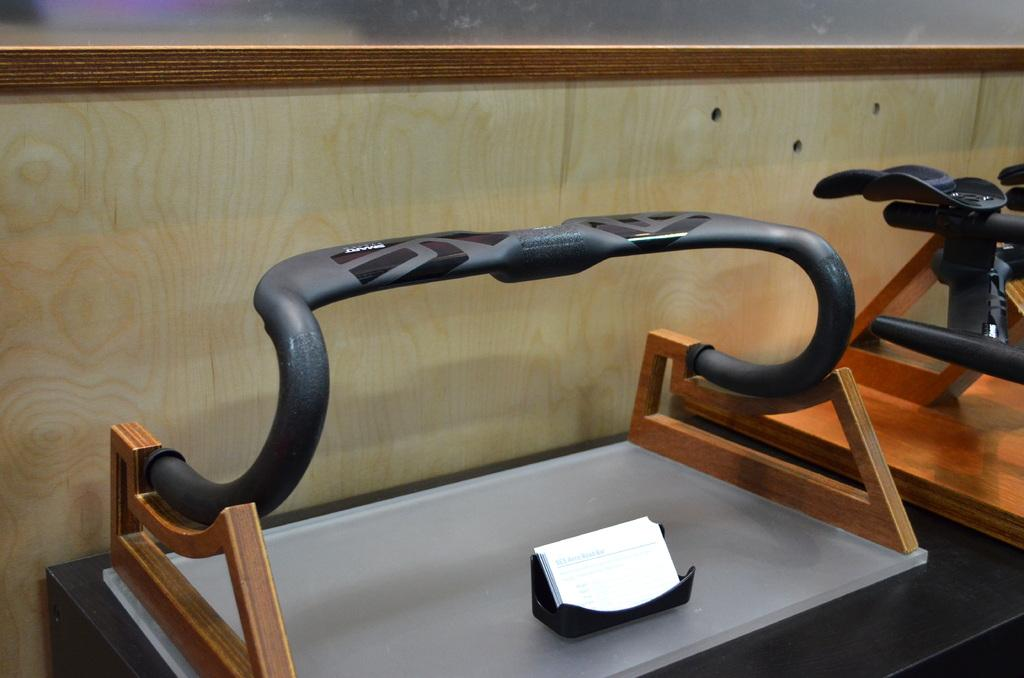What type of stand is in the image? There is a wooden stand in the image. What feature does the wooden stand have? The wooden stand has a handle. Can you describe the handle's position in relation to the stand? There is a part of the handle visible beside the stand. What type of butter can be seen on the wooden stand in the image? There is no butter present in the image; it only features a wooden stand with a handle. 